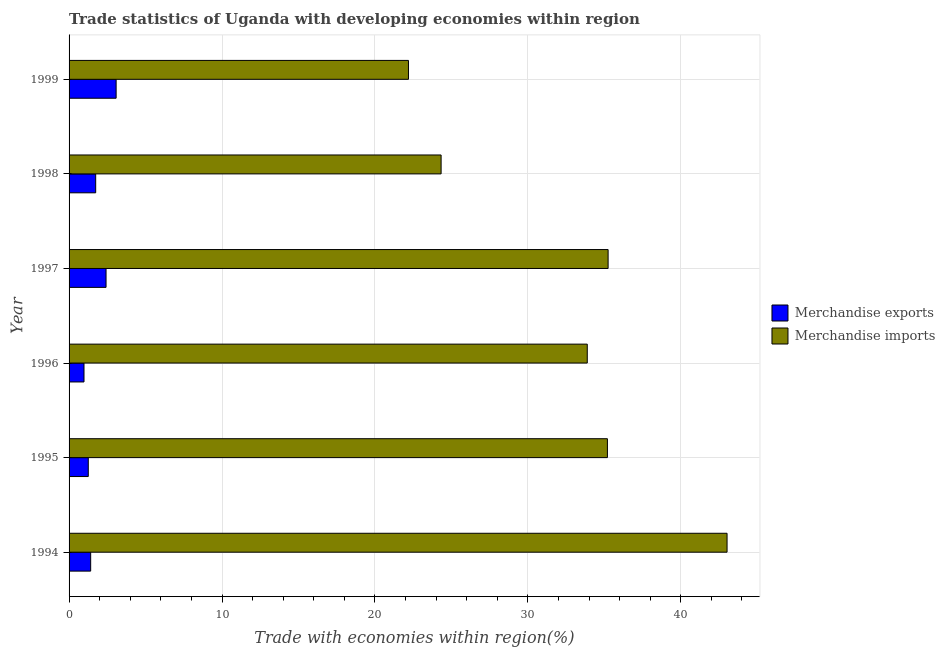How many groups of bars are there?
Your response must be concise. 6. Are the number of bars per tick equal to the number of legend labels?
Offer a very short reply. Yes. How many bars are there on the 3rd tick from the top?
Provide a short and direct response. 2. What is the merchandise imports in 1998?
Give a very brief answer. 24.33. Across all years, what is the maximum merchandise exports?
Ensure brevity in your answer.  3.08. Across all years, what is the minimum merchandise imports?
Offer a terse response. 22.19. In which year was the merchandise exports maximum?
Give a very brief answer. 1999. In which year was the merchandise exports minimum?
Your response must be concise. 1996. What is the total merchandise imports in the graph?
Give a very brief answer. 193.87. What is the difference between the merchandise exports in 1995 and that in 1996?
Your response must be concise. 0.28. What is the difference between the merchandise exports in 1995 and the merchandise imports in 1996?
Give a very brief answer. -32.63. What is the average merchandise exports per year?
Offer a terse response. 1.81. In the year 1996, what is the difference between the merchandise imports and merchandise exports?
Offer a terse response. 32.91. In how many years, is the merchandise exports greater than 42 %?
Your answer should be very brief. 0. What is the ratio of the merchandise imports in 1994 to that in 1998?
Ensure brevity in your answer.  1.77. Is the merchandise imports in 1994 less than that in 1999?
Offer a terse response. No. Is the difference between the merchandise exports in 1995 and 1999 greater than the difference between the merchandise imports in 1995 and 1999?
Provide a succinct answer. No. What is the difference between the highest and the second highest merchandise imports?
Offer a terse response. 7.78. What is the difference between the highest and the lowest merchandise imports?
Make the answer very short. 20.83. Is the sum of the merchandise imports in 1994 and 1996 greater than the maximum merchandise exports across all years?
Your answer should be very brief. Yes. What does the 1st bar from the bottom in 1998 represents?
Keep it short and to the point. Merchandise exports. How many bars are there?
Give a very brief answer. 12. Are all the bars in the graph horizontal?
Make the answer very short. Yes. What is the difference between two consecutive major ticks on the X-axis?
Provide a succinct answer. 10. Are the values on the major ticks of X-axis written in scientific E-notation?
Ensure brevity in your answer.  No. Does the graph contain any zero values?
Keep it short and to the point. No. Does the graph contain grids?
Give a very brief answer. Yes. Where does the legend appear in the graph?
Your answer should be very brief. Center right. How many legend labels are there?
Make the answer very short. 2. How are the legend labels stacked?
Your answer should be compact. Vertical. What is the title of the graph?
Your answer should be compact. Trade statistics of Uganda with developing economies within region. What is the label or title of the X-axis?
Keep it short and to the point. Trade with economies within region(%). What is the label or title of the Y-axis?
Your response must be concise. Year. What is the Trade with economies within region(%) in Merchandise exports in 1994?
Make the answer very short. 1.41. What is the Trade with economies within region(%) in Merchandise imports in 1994?
Offer a terse response. 43.02. What is the Trade with economies within region(%) in Merchandise exports in 1995?
Make the answer very short. 1.26. What is the Trade with economies within region(%) in Merchandise imports in 1995?
Provide a short and direct response. 35.2. What is the Trade with economies within region(%) of Merchandise exports in 1996?
Give a very brief answer. 0.98. What is the Trade with economies within region(%) in Merchandise imports in 1996?
Provide a short and direct response. 33.88. What is the Trade with economies within region(%) in Merchandise exports in 1997?
Your response must be concise. 2.42. What is the Trade with economies within region(%) in Merchandise imports in 1997?
Ensure brevity in your answer.  35.25. What is the Trade with economies within region(%) in Merchandise exports in 1998?
Give a very brief answer. 1.74. What is the Trade with economies within region(%) of Merchandise imports in 1998?
Provide a succinct answer. 24.33. What is the Trade with economies within region(%) of Merchandise exports in 1999?
Keep it short and to the point. 3.08. What is the Trade with economies within region(%) of Merchandise imports in 1999?
Keep it short and to the point. 22.19. Across all years, what is the maximum Trade with economies within region(%) of Merchandise exports?
Provide a succinct answer. 3.08. Across all years, what is the maximum Trade with economies within region(%) in Merchandise imports?
Your answer should be very brief. 43.02. Across all years, what is the minimum Trade with economies within region(%) of Merchandise exports?
Keep it short and to the point. 0.98. Across all years, what is the minimum Trade with economies within region(%) in Merchandise imports?
Provide a short and direct response. 22.19. What is the total Trade with economies within region(%) of Merchandise exports in the graph?
Ensure brevity in your answer.  10.88. What is the total Trade with economies within region(%) of Merchandise imports in the graph?
Make the answer very short. 193.87. What is the difference between the Trade with economies within region(%) of Merchandise exports in 1994 and that in 1995?
Offer a terse response. 0.16. What is the difference between the Trade with economies within region(%) of Merchandise imports in 1994 and that in 1995?
Provide a short and direct response. 7.82. What is the difference between the Trade with economies within region(%) in Merchandise exports in 1994 and that in 1996?
Your answer should be very brief. 0.44. What is the difference between the Trade with economies within region(%) in Merchandise imports in 1994 and that in 1996?
Provide a short and direct response. 9.14. What is the difference between the Trade with economies within region(%) in Merchandise exports in 1994 and that in 1997?
Offer a very short reply. -1.01. What is the difference between the Trade with economies within region(%) of Merchandise imports in 1994 and that in 1997?
Your answer should be compact. 7.78. What is the difference between the Trade with economies within region(%) of Merchandise exports in 1994 and that in 1998?
Give a very brief answer. -0.33. What is the difference between the Trade with economies within region(%) in Merchandise imports in 1994 and that in 1998?
Your answer should be compact. 18.7. What is the difference between the Trade with economies within region(%) in Merchandise exports in 1994 and that in 1999?
Offer a terse response. -1.66. What is the difference between the Trade with economies within region(%) in Merchandise imports in 1994 and that in 1999?
Your answer should be compact. 20.83. What is the difference between the Trade with economies within region(%) in Merchandise exports in 1995 and that in 1996?
Provide a succinct answer. 0.28. What is the difference between the Trade with economies within region(%) in Merchandise imports in 1995 and that in 1996?
Make the answer very short. 1.32. What is the difference between the Trade with economies within region(%) of Merchandise exports in 1995 and that in 1997?
Offer a very short reply. -1.16. What is the difference between the Trade with economies within region(%) of Merchandise imports in 1995 and that in 1997?
Provide a short and direct response. -0.05. What is the difference between the Trade with economies within region(%) of Merchandise exports in 1995 and that in 1998?
Your answer should be compact. -0.48. What is the difference between the Trade with economies within region(%) of Merchandise imports in 1995 and that in 1998?
Provide a succinct answer. 10.87. What is the difference between the Trade with economies within region(%) in Merchandise exports in 1995 and that in 1999?
Ensure brevity in your answer.  -1.82. What is the difference between the Trade with economies within region(%) in Merchandise imports in 1995 and that in 1999?
Your response must be concise. 13.01. What is the difference between the Trade with economies within region(%) in Merchandise exports in 1996 and that in 1997?
Your answer should be compact. -1.44. What is the difference between the Trade with economies within region(%) in Merchandise imports in 1996 and that in 1997?
Provide a short and direct response. -1.36. What is the difference between the Trade with economies within region(%) in Merchandise exports in 1996 and that in 1998?
Provide a succinct answer. -0.76. What is the difference between the Trade with economies within region(%) of Merchandise imports in 1996 and that in 1998?
Keep it short and to the point. 9.56. What is the difference between the Trade with economies within region(%) in Merchandise exports in 1996 and that in 1999?
Give a very brief answer. -2.1. What is the difference between the Trade with economies within region(%) in Merchandise imports in 1996 and that in 1999?
Your answer should be compact. 11.69. What is the difference between the Trade with economies within region(%) of Merchandise exports in 1997 and that in 1998?
Offer a terse response. 0.68. What is the difference between the Trade with economies within region(%) in Merchandise imports in 1997 and that in 1998?
Offer a very short reply. 10.92. What is the difference between the Trade with economies within region(%) in Merchandise exports in 1997 and that in 1999?
Give a very brief answer. -0.66. What is the difference between the Trade with economies within region(%) of Merchandise imports in 1997 and that in 1999?
Ensure brevity in your answer.  13.05. What is the difference between the Trade with economies within region(%) of Merchandise exports in 1998 and that in 1999?
Your answer should be compact. -1.34. What is the difference between the Trade with economies within region(%) of Merchandise imports in 1998 and that in 1999?
Your answer should be very brief. 2.13. What is the difference between the Trade with economies within region(%) in Merchandise exports in 1994 and the Trade with economies within region(%) in Merchandise imports in 1995?
Keep it short and to the point. -33.79. What is the difference between the Trade with economies within region(%) in Merchandise exports in 1994 and the Trade with economies within region(%) in Merchandise imports in 1996?
Provide a short and direct response. -32.47. What is the difference between the Trade with economies within region(%) in Merchandise exports in 1994 and the Trade with economies within region(%) in Merchandise imports in 1997?
Ensure brevity in your answer.  -33.83. What is the difference between the Trade with economies within region(%) of Merchandise exports in 1994 and the Trade with economies within region(%) of Merchandise imports in 1998?
Make the answer very short. -22.91. What is the difference between the Trade with economies within region(%) in Merchandise exports in 1994 and the Trade with economies within region(%) in Merchandise imports in 1999?
Offer a very short reply. -20.78. What is the difference between the Trade with economies within region(%) in Merchandise exports in 1995 and the Trade with economies within region(%) in Merchandise imports in 1996?
Your answer should be compact. -32.63. What is the difference between the Trade with economies within region(%) of Merchandise exports in 1995 and the Trade with economies within region(%) of Merchandise imports in 1997?
Offer a very short reply. -33.99. What is the difference between the Trade with economies within region(%) in Merchandise exports in 1995 and the Trade with economies within region(%) in Merchandise imports in 1998?
Provide a succinct answer. -23.07. What is the difference between the Trade with economies within region(%) of Merchandise exports in 1995 and the Trade with economies within region(%) of Merchandise imports in 1999?
Provide a succinct answer. -20.94. What is the difference between the Trade with economies within region(%) of Merchandise exports in 1996 and the Trade with economies within region(%) of Merchandise imports in 1997?
Provide a short and direct response. -34.27. What is the difference between the Trade with economies within region(%) in Merchandise exports in 1996 and the Trade with economies within region(%) in Merchandise imports in 1998?
Offer a terse response. -23.35. What is the difference between the Trade with economies within region(%) of Merchandise exports in 1996 and the Trade with economies within region(%) of Merchandise imports in 1999?
Ensure brevity in your answer.  -21.22. What is the difference between the Trade with economies within region(%) of Merchandise exports in 1997 and the Trade with economies within region(%) of Merchandise imports in 1998?
Your answer should be compact. -21.91. What is the difference between the Trade with economies within region(%) of Merchandise exports in 1997 and the Trade with economies within region(%) of Merchandise imports in 1999?
Make the answer very short. -19.77. What is the difference between the Trade with economies within region(%) in Merchandise exports in 1998 and the Trade with economies within region(%) in Merchandise imports in 1999?
Your answer should be very brief. -20.45. What is the average Trade with economies within region(%) of Merchandise exports per year?
Your response must be concise. 1.81. What is the average Trade with economies within region(%) in Merchandise imports per year?
Your answer should be very brief. 32.31. In the year 1994, what is the difference between the Trade with economies within region(%) of Merchandise exports and Trade with economies within region(%) of Merchandise imports?
Your answer should be compact. -41.61. In the year 1995, what is the difference between the Trade with economies within region(%) in Merchandise exports and Trade with economies within region(%) in Merchandise imports?
Keep it short and to the point. -33.94. In the year 1996, what is the difference between the Trade with economies within region(%) of Merchandise exports and Trade with economies within region(%) of Merchandise imports?
Make the answer very short. -32.91. In the year 1997, what is the difference between the Trade with economies within region(%) of Merchandise exports and Trade with economies within region(%) of Merchandise imports?
Keep it short and to the point. -32.83. In the year 1998, what is the difference between the Trade with economies within region(%) in Merchandise exports and Trade with economies within region(%) in Merchandise imports?
Offer a terse response. -22.59. In the year 1999, what is the difference between the Trade with economies within region(%) in Merchandise exports and Trade with economies within region(%) in Merchandise imports?
Make the answer very short. -19.12. What is the ratio of the Trade with economies within region(%) in Merchandise exports in 1994 to that in 1995?
Your answer should be very brief. 1.12. What is the ratio of the Trade with economies within region(%) in Merchandise imports in 1994 to that in 1995?
Offer a terse response. 1.22. What is the ratio of the Trade with economies within region(%) of Merchandise exports in 1994 to that in 1996?
Your answer should be compact. 1.45. What is the ratio of the Trade with economies within region(%) of Merchandise imports in 1994 to that in 1996?
Ensure brevity in your answer.  1.27. What is the ratio of the Trade with economies within region(%) in Merchandise exports in 1994 to that in 1997?
Ensure brevity in your answer.  0.58. What is the ratio of the Trade with economies within region(%) in Merchandise imports in 1994 to that in 1997?
Your answer should be compact. 1.22. What is the ratio of the Trade with economies within region(%) in Merchandise exports in 1994 to that in 1998?
Offer a very short reply. 0.81. What is the ratio of the Trade with economies within region(%) of Merchandise imports in 1994 to that in 1998?
Provide a short and direct response. 1.77. What is the ratio of the Trade with economies within region(%) in Merchandise exports in 1994 to that in 1999?
Give a very brief answer. 0.46. What is the ratio of the Trade with economies within region(%) of Merchandise imports in 1994 to that in 1999?
Your answer should be compact. 1.94. What is the ratio of the Trade with economies within region(%) in Merchandise exports in 1995 to that in 1996?
Keep it short and to the point. 1.29. What is the ratio of the Trade with economies within region(%) in Merchandise imports in 1995 to that in 1996?
Offer a terse response. 1.04. What is the ratio of the Trade with economies within region(%) of Merchandise exports in 1995 to that in 1997?
Give a very brief answer. 0.52. What is the ratio of the Trade with economies within region(%) of Merchandise exports in 1995 to that in 1998?
Provide a succinct answer. 0.72. What is the ratio of the Trade with economies within region(%) of Merchandise imports in 1995 to that in 1998?
Your answer should be very brief. 1.45. What is the ratio of the Trade with economies within region(%) of Merchandise exports in 1995 to that in 1999?
Your answer should be very brief. 0.41. What is the ratio of the Trade with economies within region(%) of Merchandise imports in 1995 to that in 1999?
Provide a succinct answer. 1.59. What is the ratio of the Trade with economies within region(%) of Merchandise exports in 1996 to that in 1997?
Offer a very short reply. 0.4. What is the ratio of the Trade with economies within region(%) of Merchandise imports in 1996 to that in 1997?
Your response must be concise. 0.96. What is the ratio of the Trade with economies within region(%) of Merchandise exports in 1996 to that in 1998?
Provide a succinct answer. 0.56. What is the ratio of the Trade with economies within region(%) in Merchandise imports in 1996 to that in 1998?
Your answer should be very brief. 1.39. What is the ratio of the Trade with economies within region(%) in Merchandise exports in 1996 to that in 1999?
Offer a very short reply. 0.32. What is the ratio of the Trade with economies within region(%) of Merchandise imports in 1996 to that in 1999?
Your answer should be compact. 1.53. What is the ratio of the Trade with economies within region(%) of Merchandise exports in 1997 to that in 1998?
Give a very brief answer. 1.39. What is the ratio of the Trade with economies within region(%) of Merchandise imports in 1997 to that in 1998?
Your response must be concise. 1.45. What is the ratio of the Trade with economies within region(%) of Merchandise exports in 1997 to that in 1999?
Offer a very short reply. 0.79. What is the ratio of the Trade with economies within region(%) of Merchandise imports in 1997 to that in 1999?
Keep it short and to the point. 1.59. What is the ratio of the Trade with economies within region(%) in Merchandise exports in 1998 to that in 1999?
Keep it short and to the point. 0.57. What is the ratio of the Trade with economies within region(%) in Merchandise imports in 1998 to that in 1999?
Provide a short and direct response. 1.1. What is the difference between the highest and the second highest Trade with economies within region(%) of Merchandise exports?
Provide a short and direct response. 0.66. What is the difference between the highest and the second highest Trade with economies within region(%) in Merchandise imports?
Make the answer very short. 7.78. What is the difference between the highest and the lowest Trade with economies within region(%) of Merchandise exports?
Give a very brief answer. 2.1. What is the difference between the highest and the lowest Trade with economies within region(%) in Merchandise imports?
Your response must be concise. 20.83. 